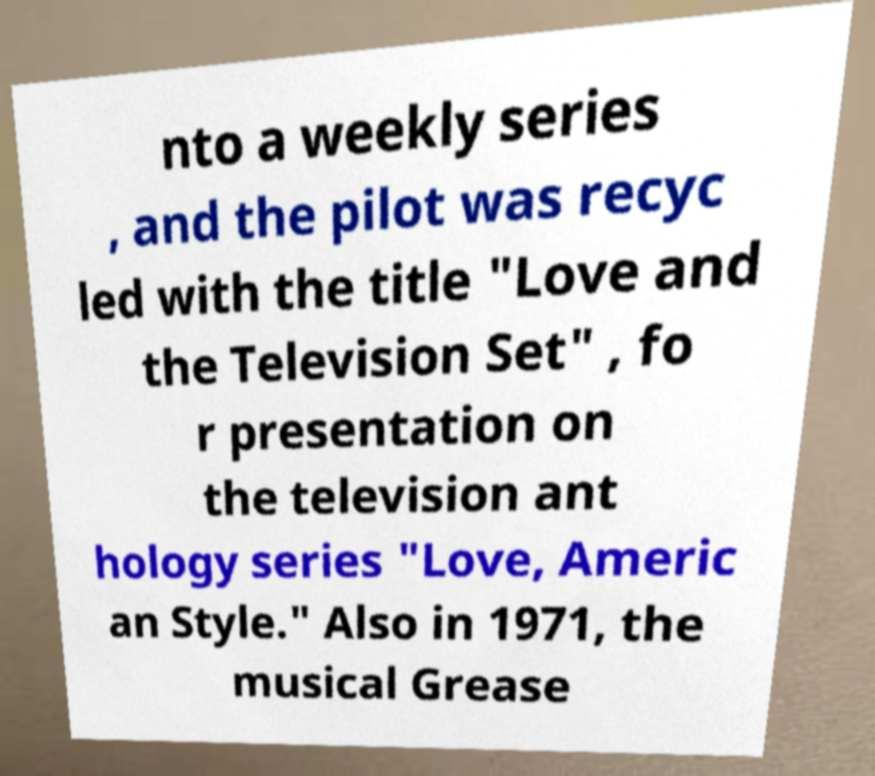Could you assist in decoding the text presented in this image and type it out clearly? nto a weekly series , and the pilot was recyc led with the title "Love and the Television Set" , fo r presentation on the television ant hology series "Love, Americ an Style." Also in 1971, the musical Grease 